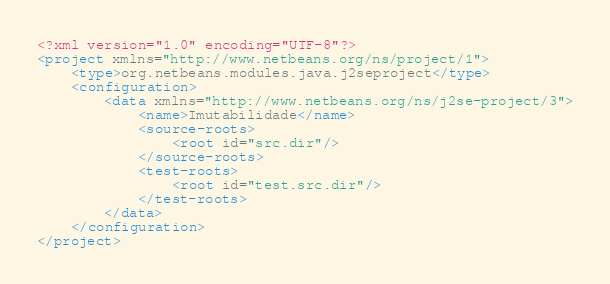<code> <loc_0><loc_0><loc_500><loc_500><_XML_><?xml version="1.0" encoding="UTF-8"?>
<project xmlns="http://www.netbeans.org/ns/project/1">
    <type>org.netbeans.modules.java.j2seproject</type>
    <configuration>
        <data xmlns="http://www.netbeans.org/ns/j2se-project/3">
            <name>Imutabilidade</name>
            <source-roots>
                <root id="src.dir"/>
            </source-roots>
            <test-roots>
                <root id="test.src.dir"/>
            </test-roots>
        </data>
    </configuration>
</project>
</code> 